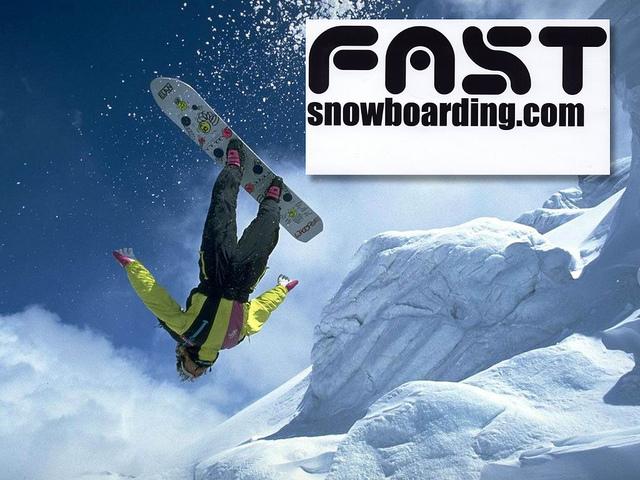Is this a landscape of stone?
Write a very short answer. No. Is this man flying?
Keep it brief. No. Where is he facing?
Keep it brief. Down. 